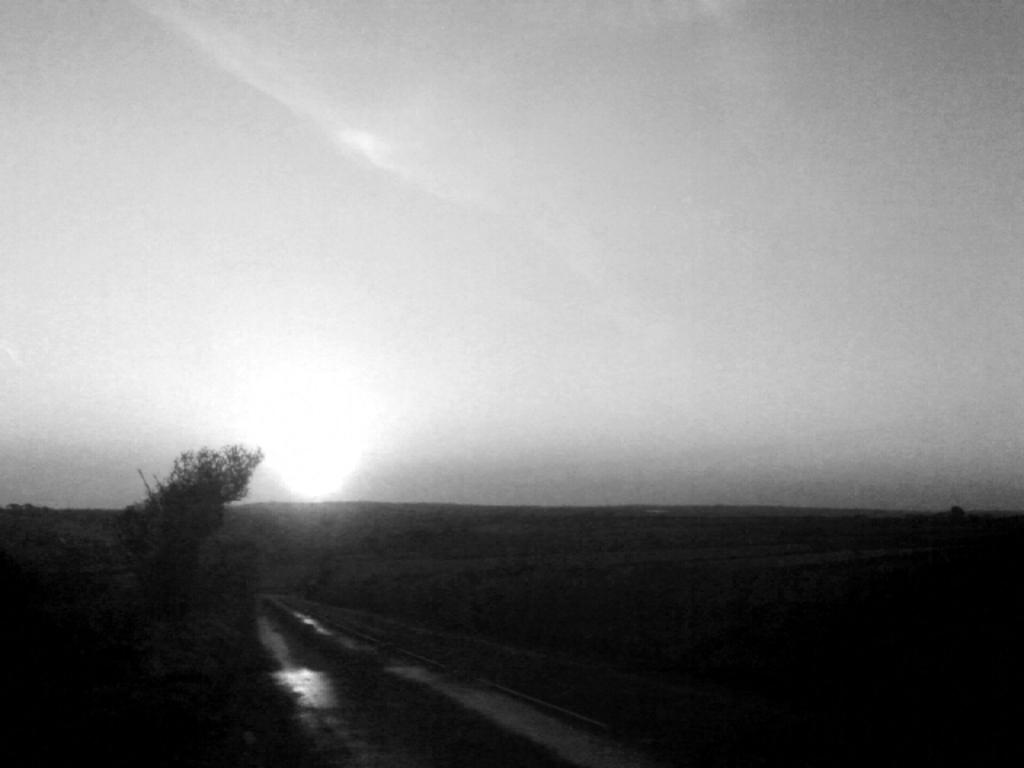What is the color scheme of the image? The image is black and white. What type of terrain can be seen at the bottom of the image? There is ground visible at the bottom of the image. What is located on the left side of the image? There is a tree on the left side of the image. What is visible at the top of the image? The sky is visible at the top of the image. Where is the faucet located in the image? There is no faucet present in the image. What type of blood vessels can be seen in the image? There is no reference to blood vessels or blood in the image; it is a black and white image featuring ground, a tree, and the sky. 